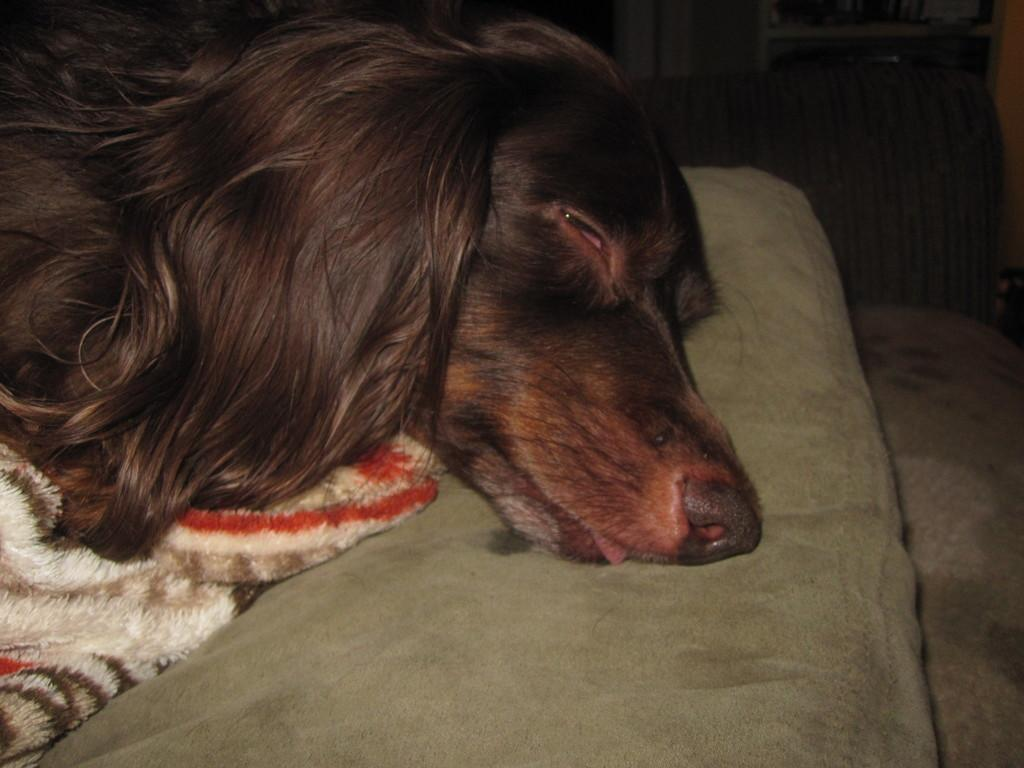What animal can be seen in the image? There is a dog in the image. Where is the dog located? The dog is on a couch. What is located beside the dog? There is a blanket beside the dog. What can be seen in the background of the image? There is a wall visible in the image. What type of objects are on shelves in the image? There are objects on shelves in the image. What type of wristwatch is the dog wearing in the image? The dog is not wearing a wristwatch in the image; it is a dog, and animals do not wear wristwatches. 